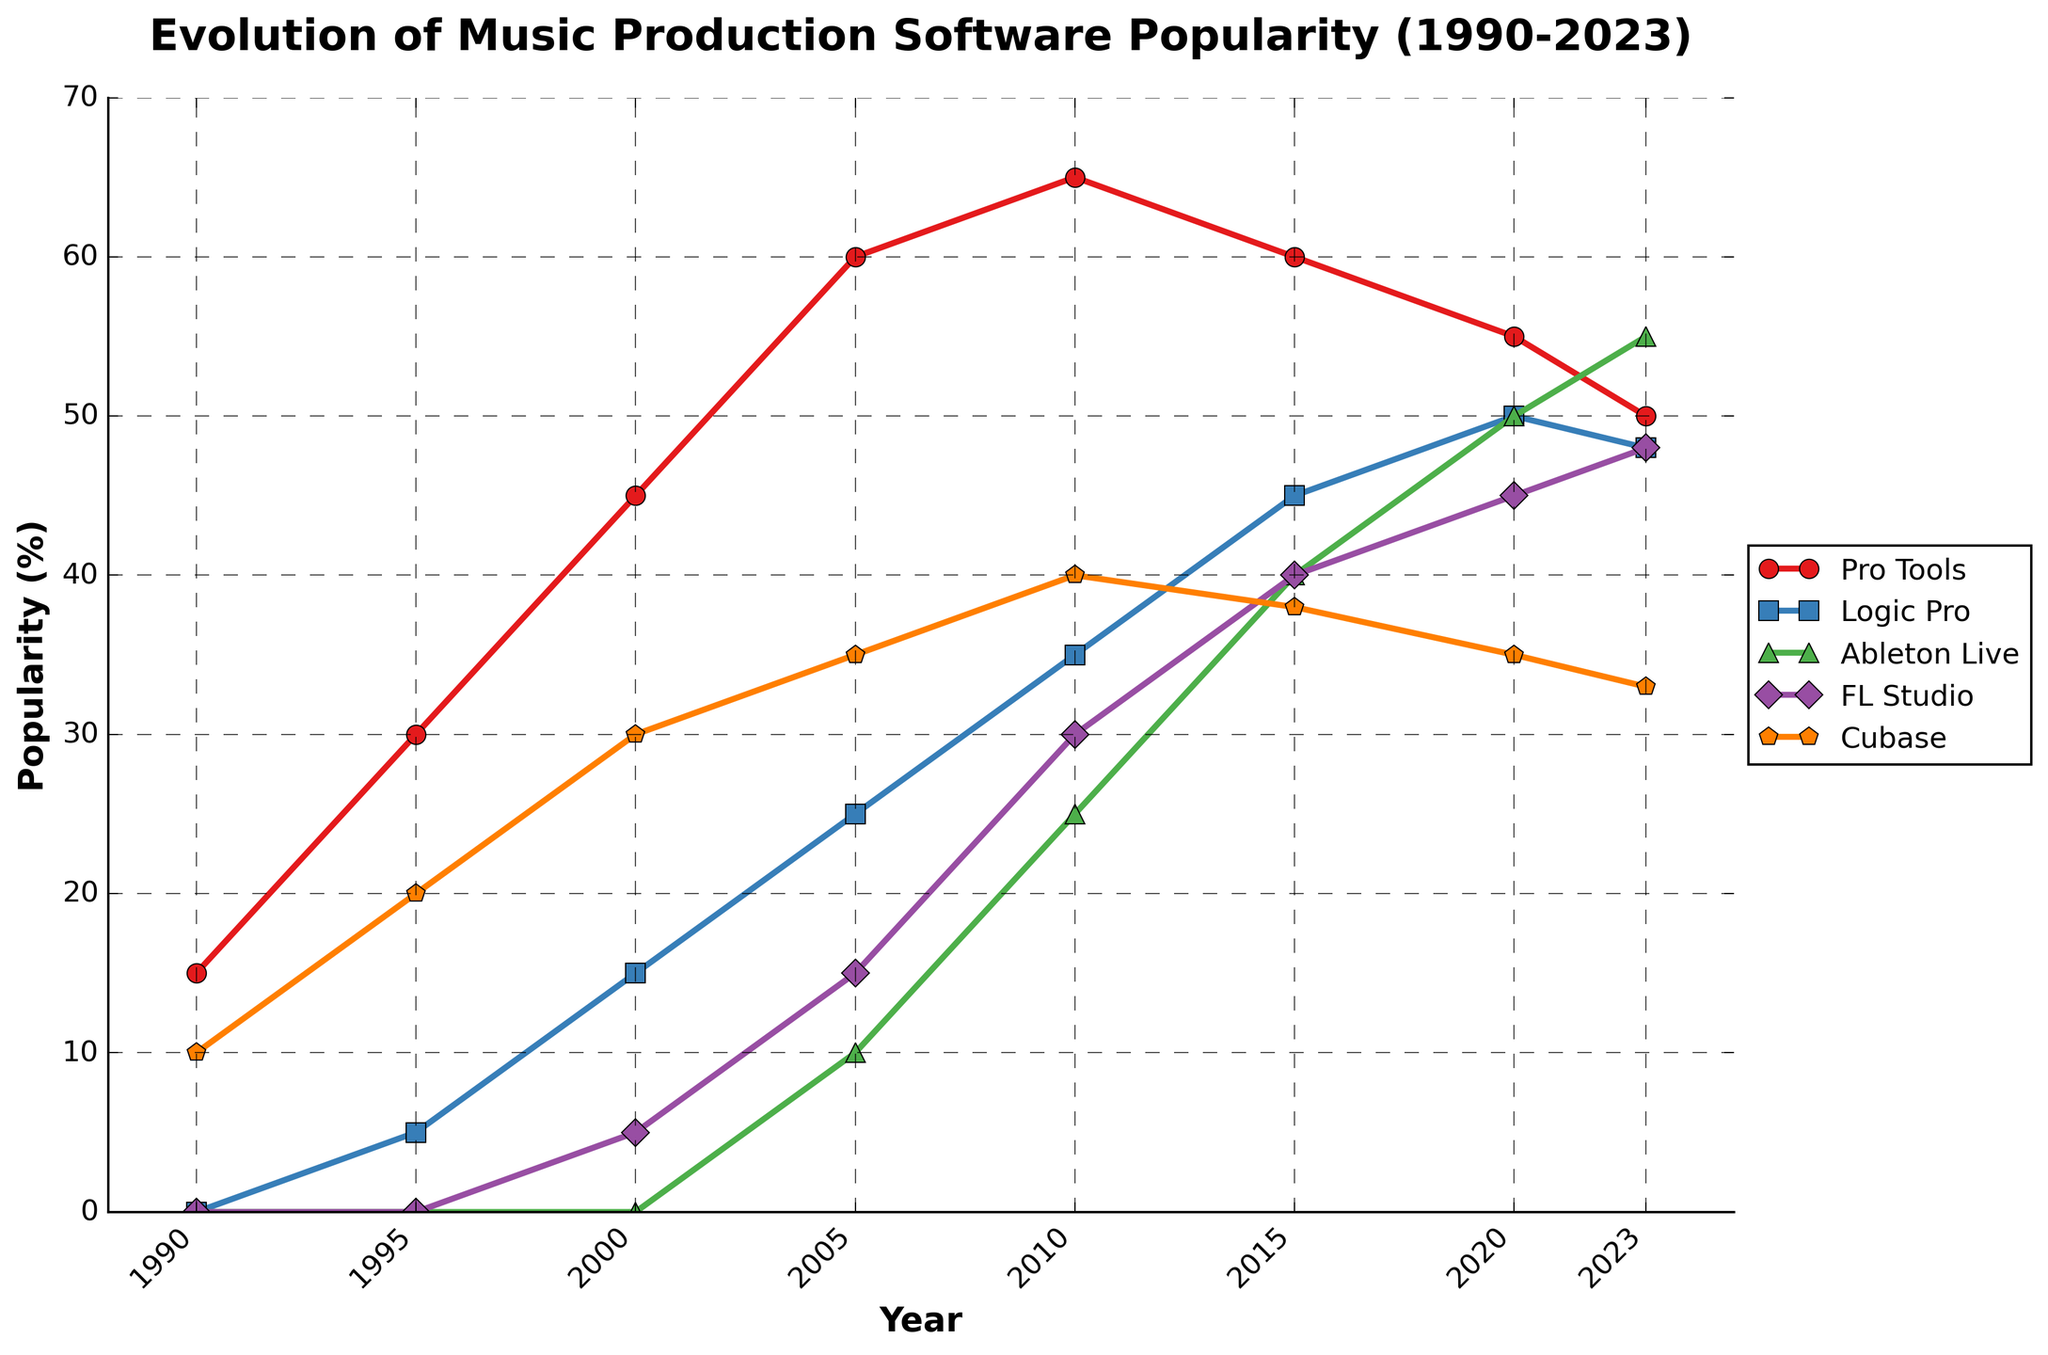How many years did FL Studio have a higher popularity than Ableton Live? FL Studio had higher popularity than Ableton Live in the years 2000, 2005, and 2010. By checking each interval, we see Ableton Live was higher in the years 2015, 2020, and 2023. Therefore, FL Studio had higher popularity for 3 years.
Answer: 3 Which software started seeing a decline in popularity after 2010? By observing the slopes of the lines on the chart, we see that Pro Tools started declining after 2010, dropping from 65% in 2010 to 50% in 2023.
Answer: Pro Tools What is the difference in popularity between the most popular and the least popular software in 2023? From the chart, the most popular software in 2023 is Ableton Live at 55%, and the least popular software is Cubase at 33%. The difference is 55% - 33% = 22%.
Answer: 22% Which software showed the most consistent increase in popularity until 2015? The line representing Logic Pro shows a steady increase from around 5% in 1995 to 45% in 2015, without any declines, indicating the most consistent increase.
Answer: Logic Pro What is the average popularity of Cubase over the entire period? The data points for Cubase are 10, 20, 30, 35, 40, 38, 35, and 33. Summing these up gives 241. Dividing by the total number of points (8) gives an average of 30.125.
Answer: 30.125 Which two softwares had nearly equal popularity in 2020? Observing the line chart for 2020, both Logic Pro and FL Studio had a popularity of around 50% and 45% respectively, making them closest in this year.
Answer: Logic Pro and FL Studio What trend did Ableton Live follow from 2005 to 2023? From 2005, Ableton Live rose from 10% to 25% in 2010, then to 40% in 2015, 50% in 2020, and further to 55% in 2023, showing a consistent increase throughout these years.
Answer: Increasing What was the popularity difference between Pro Tools and Cubase in 1995? In 1995, Pro Tools had a popularity of 30%, and Cubase had 20%. The difference is 30% - 20% = 10%.
Answer: 10% Between 2015 and 2020, which software had the largest gain in popularity? By comparing the popularity values in 2015 and 2020, Logic Pro increased from 45% to 50% (gain of 5%), Ableton Live from 40% to 50% (10% gain), FL Studio from 40% to 45% (5% gain), and Pro Tools decreased, Cubase decreased. Thus, Ableton Live had the largest gain.
Answer: Ableton Live 